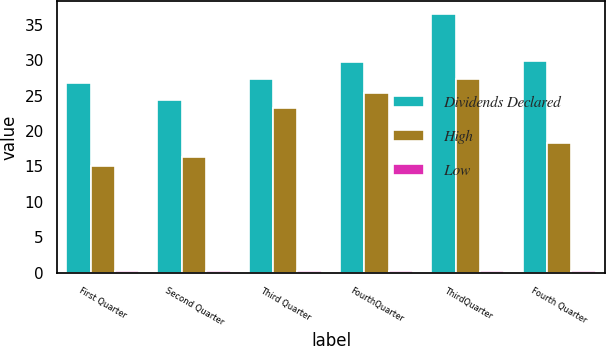<chart> <loc_0><loc_0><loc_500><loc_500><stacked_bar_chart><ecel><fcel>First Quarter<fcel>Second Quarter<fcel>Third Quarter<fcel>FourthQuarter<fcel>ThirdQuarter<fcel>Fourth Quarter<nl><fcel>Dividends Declared<fcel>26.81<fcel>24.45<fcel>27.34<fcel>29.82<fcel>36.52<fcel>29.96<nl><fcel>High<fcel>15.05<fcel>16.31<fcel>23.32<fcel>25.44<fcel>27.29<fcel>18.25<nl><fcel>Low<fcel>0.19<fcel>0.19<fcel>0.19<fcel>0.19<fcel>0.19<fcel>0.19<nl></chart> 